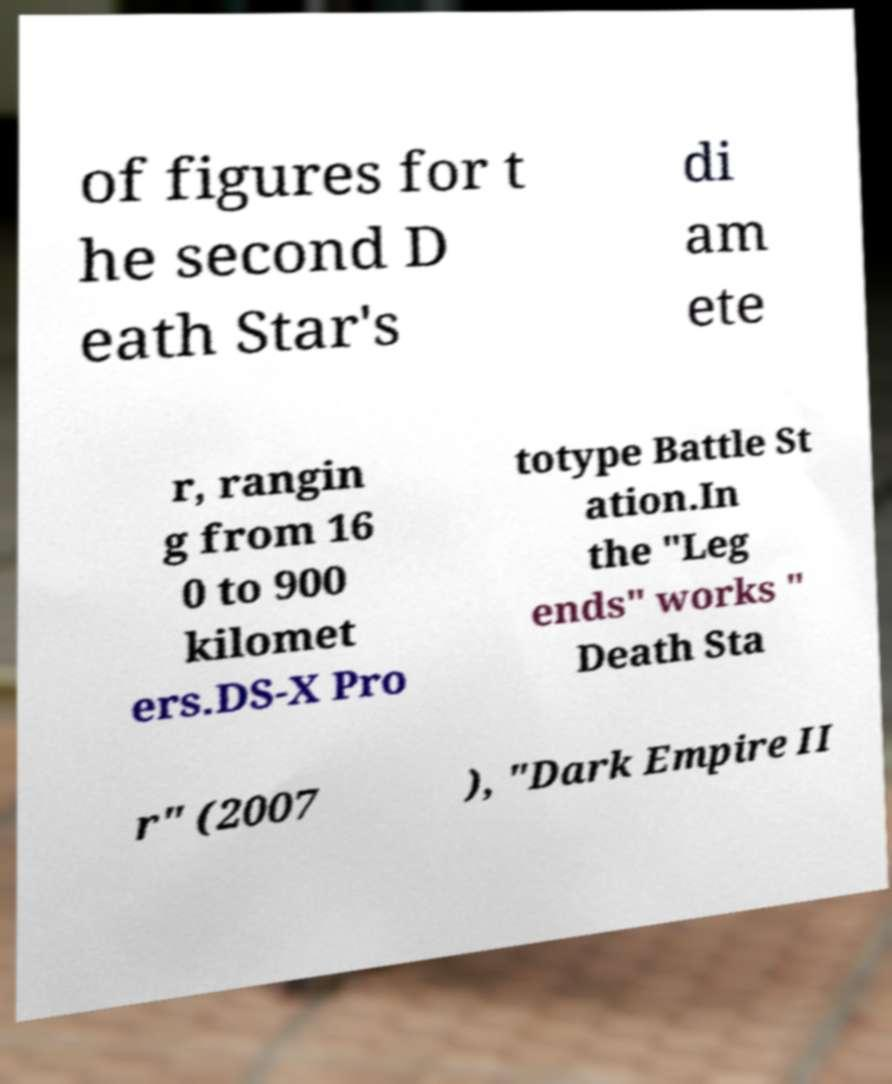I need the written content from this picture converted into text. Can you do that? of figures for t he second D eath Star's di am ete r, rangin g from 16 0 to 900 kilomet ers.DS-X Pro totype Battle St ation.In the "Leg ends" works " Death Sta r" (2007 ), "Dark Empire II 